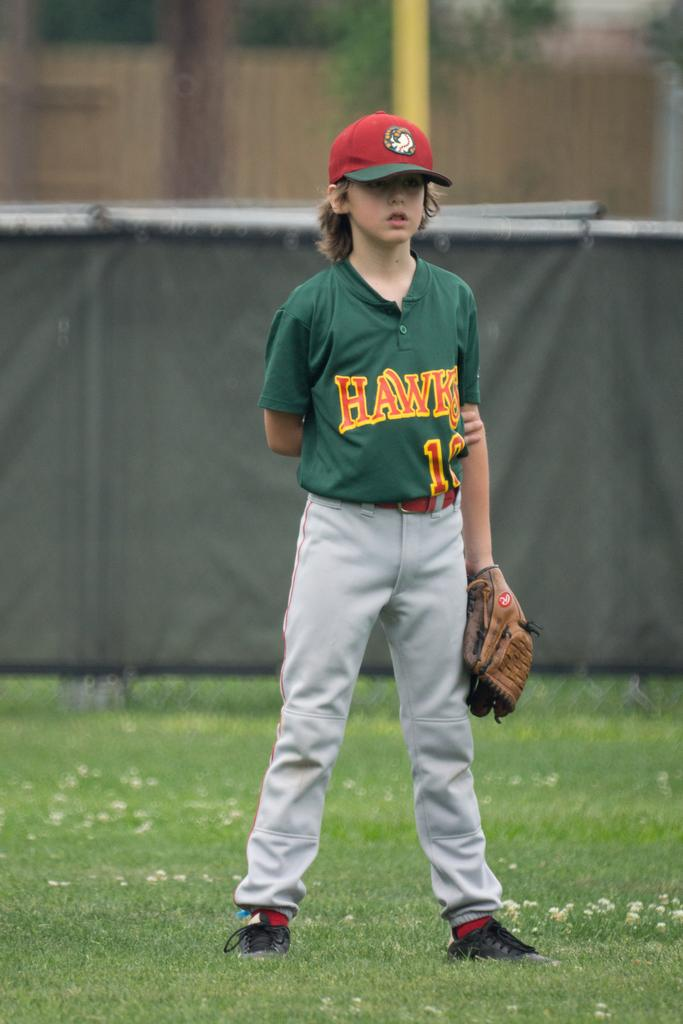<image>
Render a clear and concise summary of the photo. a young boy from the hawks baseball team standing in the outfield 